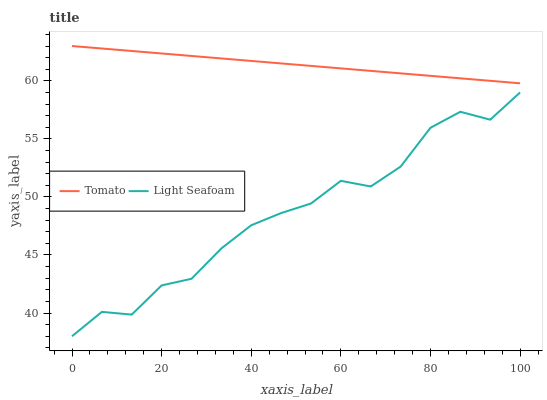Does Light Seafoam have the minimum area under the curve?
Answer yes or no. Yes. Does Tomato have the maximum area under the curve?
Answer yes or no. Yes. Does Light Seafoam have the maximum area under the curve?
Answer yes or no. No. Is Tomato the smoothest?
Answer yes or no. Yes. Is Light Seafoam the roughest?
Answer yes or no. Yes. Is Light Seafoam the smoothest?
Answer yes or no. No. Does Light Seafoam have the lowest value?
Answer yes or no. Yes. Does Tomato have the highest value?
Answer yes or no. Yes. Does Light Seafoam have the highest value?
Answer yes or no. No. Is Light Seafoam less than Tomato?
Answer yes or no. Yes. Is Tomato greater than Light Seafoam?
Answer yes or no. Yes. Does Light Seafoam intersect Tomato?
Answer yes or no. No. 